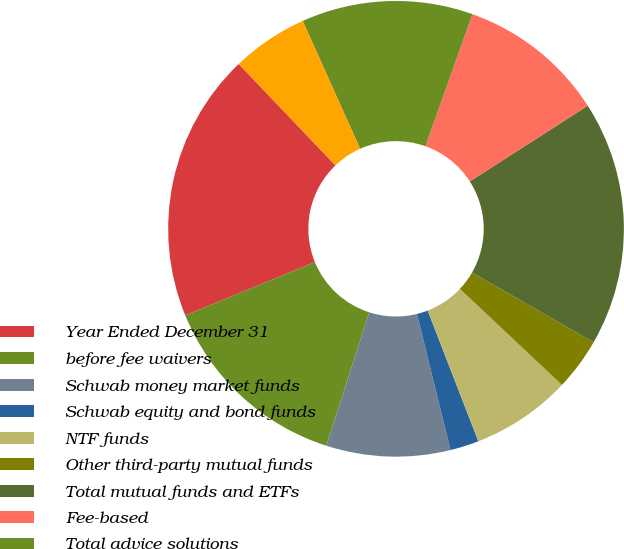Convert chart. <chart><loc_0><loc_0><loc_500><loc_500><pie_chart><fcel>Year Ended December 31<fcel>before fee waivers<fcel>Schwab money market funds<fcel>Schwab equity and bond funds<fcel>NTF funds<fcel>Other third-party mutual funds<fcel>Total mutual funds and ETFs<fcel>Fee-based<fcel>Total advice solutions<fcel>Other balance-based fees (3)<nl><fcel>19.07%<fcel>13.85%<fcel>8.79%<fcel>2.04%<fcel>7.1%<fcel>3.72%<fcel>17.38%<fcel>10.47%<fcel>12.16%<fcel>5.41%<nl></chart> 